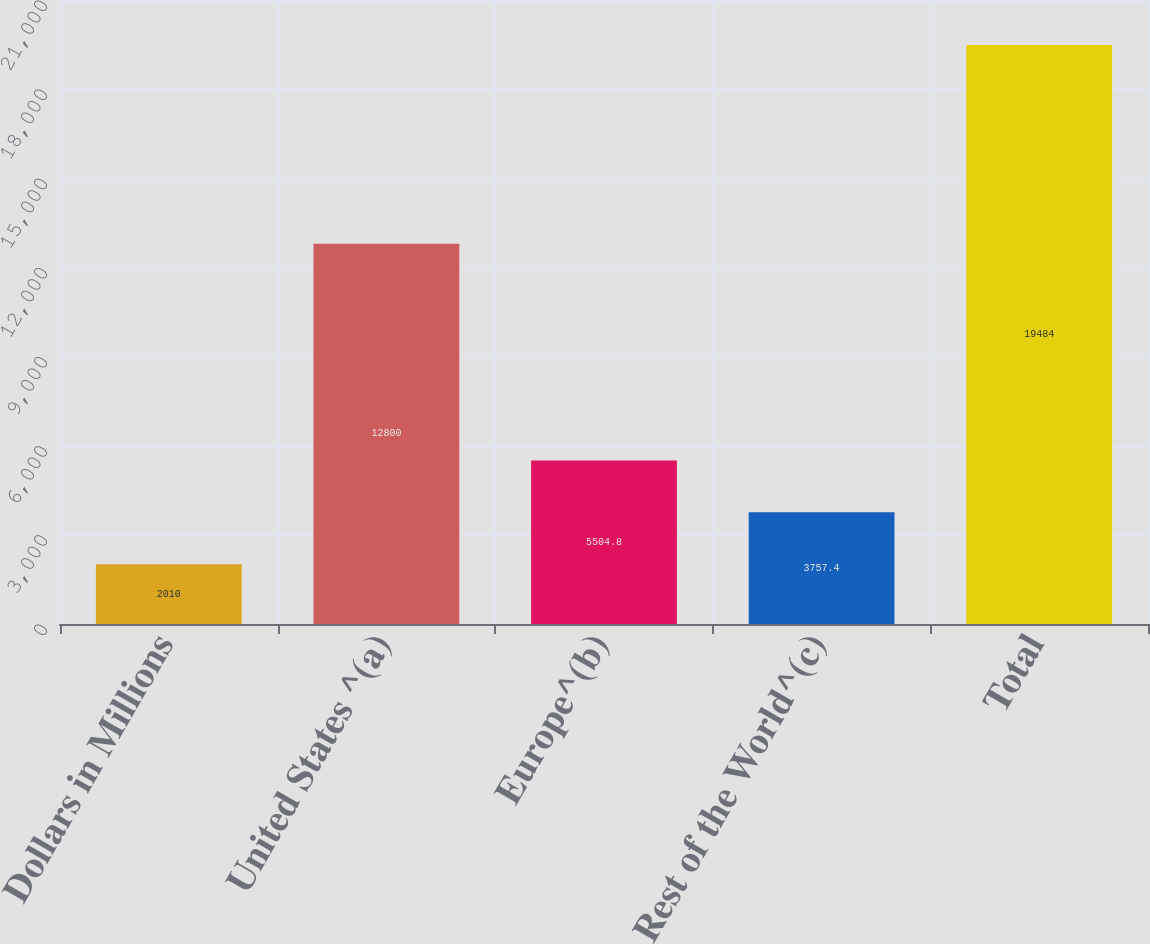<chart> <loc_0><loc_0><loc_500><loc_500><bar_chart><fcel>Dollars in Millions<fcel>United States ^(a)<fcel>Europe^(b)<fcel>Rest of the World^(c)<fcel>Total<nl><fcel>2010<fcel>12800<fcel>5504.8<fcel>3757.4<fcel>19484<nl></chart> 